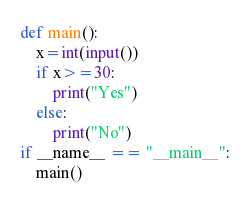<code> <loc_0><loc_0><loc_500><loc_500><_Python_>def main():
    x=int(input())
    if x>=30:
        print("Yes")
    else:
        print("No")
if __name__ == "__main__":
    main()</code> 